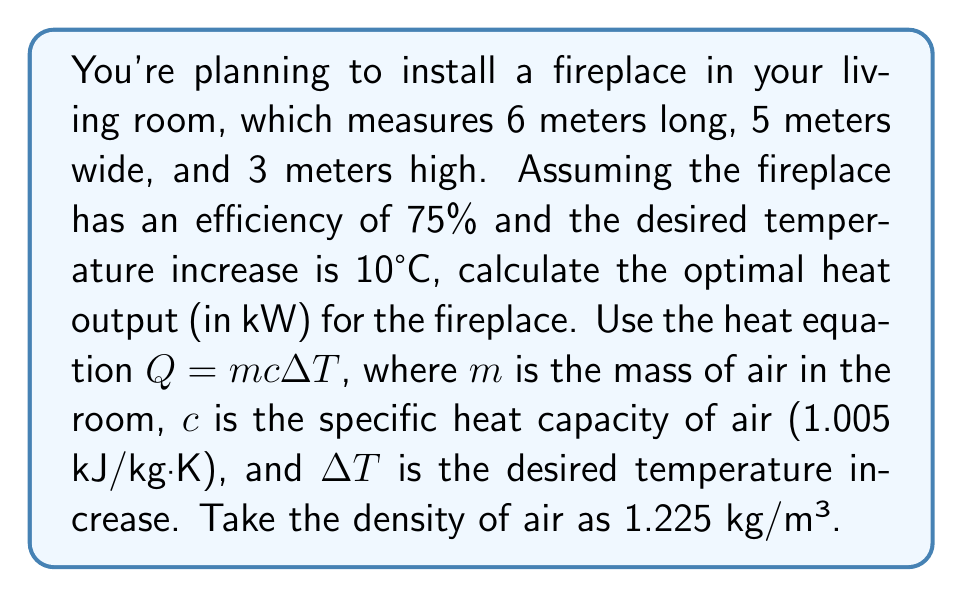Teach me how to tackle this problem. To determine the optimal heat output for the fireplace, we'll follow these steps:

1. Calculate the volume of the room:
   $V = 6\text{ m} \times 5\text{ m} \times 3\text{ m} = 90\text{ m}^3$

2. Calculate the mass of air in the room:
   $m = \text{density} \times \text{volume} = 1.225\text{ kg/m}^3 \times 90\text{ m}^3 = 110.25\text{ kg}$

3. Apply the heat equation:
   $Q = mc\Delta T$
   $Q = 110.25\text{ kg} \times 1.005\text{ kJ/kg·K} \times 10\text{ K} = 1107.76\text{ kJ}$

4. Convert kJ to kW (assuming we want to heat the room in 1 hour):
   $\text{Power} = \frac{1107.76\text{ kJ}}{3600\text{ s}} = 0.3077\text{ kW}$

5. Account for the fireplace efficiency:
   $\text{Optimal heat output} = \frac{0.3077\text{ kW}}{0.75} = 0.4103\text{ kW}$

Therefore, the optimal heat output for the fireplace is approximately 0.4103 kW.
Answer: 0.4103 kW 